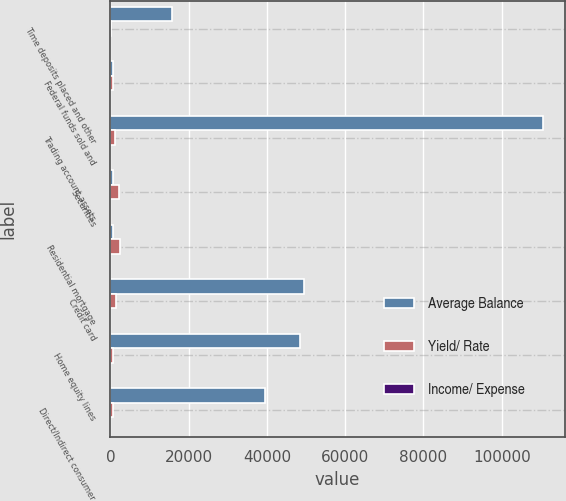Convert chart. <chart><loc_0><loc_0><loc_500><loc_500><stacked_bar_chart><ecel><fcel>Time deposits placed and other<fcel>Federal funds sold and<fcel>Trading account assets<fcel>Securities<fcel>Residential mortgage<fcel>Credit card<fcel>Home equity lines<fcel>Direct/Indirect consumer<nl><fcel>Average Balance<fcel>15620<fcel>609<fcel>110585<fcel>609<fcel>609<fcel>49366<fcel>48336<fcel>39526<nl><fcel>Yield/ Rate<fcel>128<fcel>712<fcel>1067<fcel>2083<fcel>2459<fcel>1351<fcel>609<fcel>551<nl><fcel>Income/ Expense<fcel>3.24<fcel>1.9<fcel>3.85<fcel>4.87<fcel>5.49<fcel>10.88<fcel>5.01<fcel>5.55<nl></chart> 